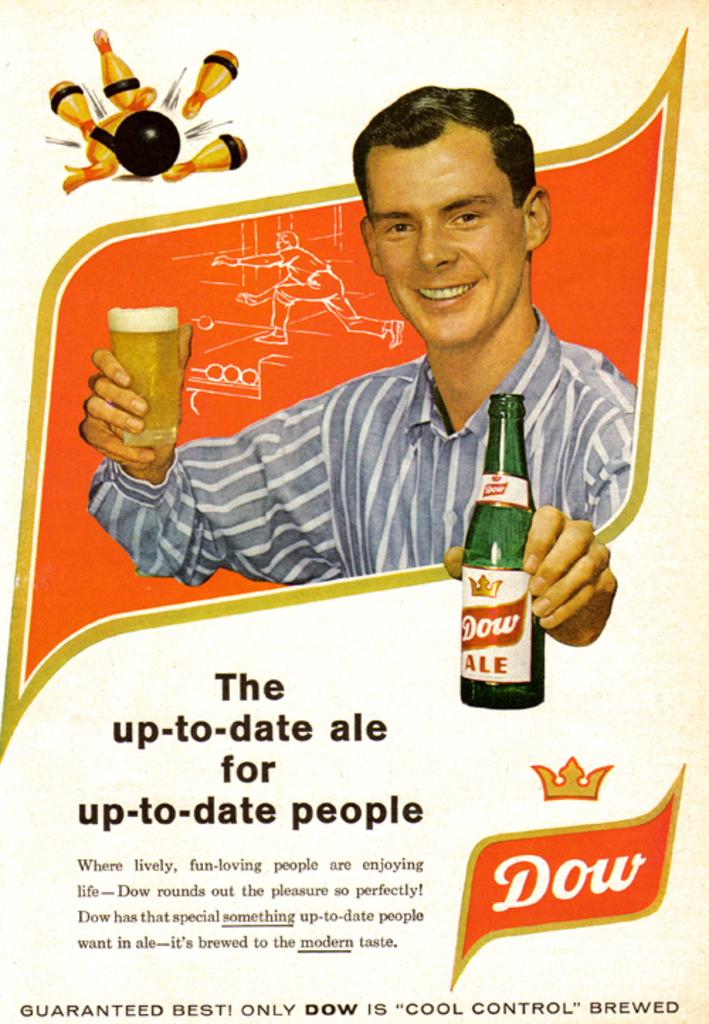<image>
Give a short and clear explanation of the subsequent image. Man holding a beer of Dow Ale and a cup of beer. 